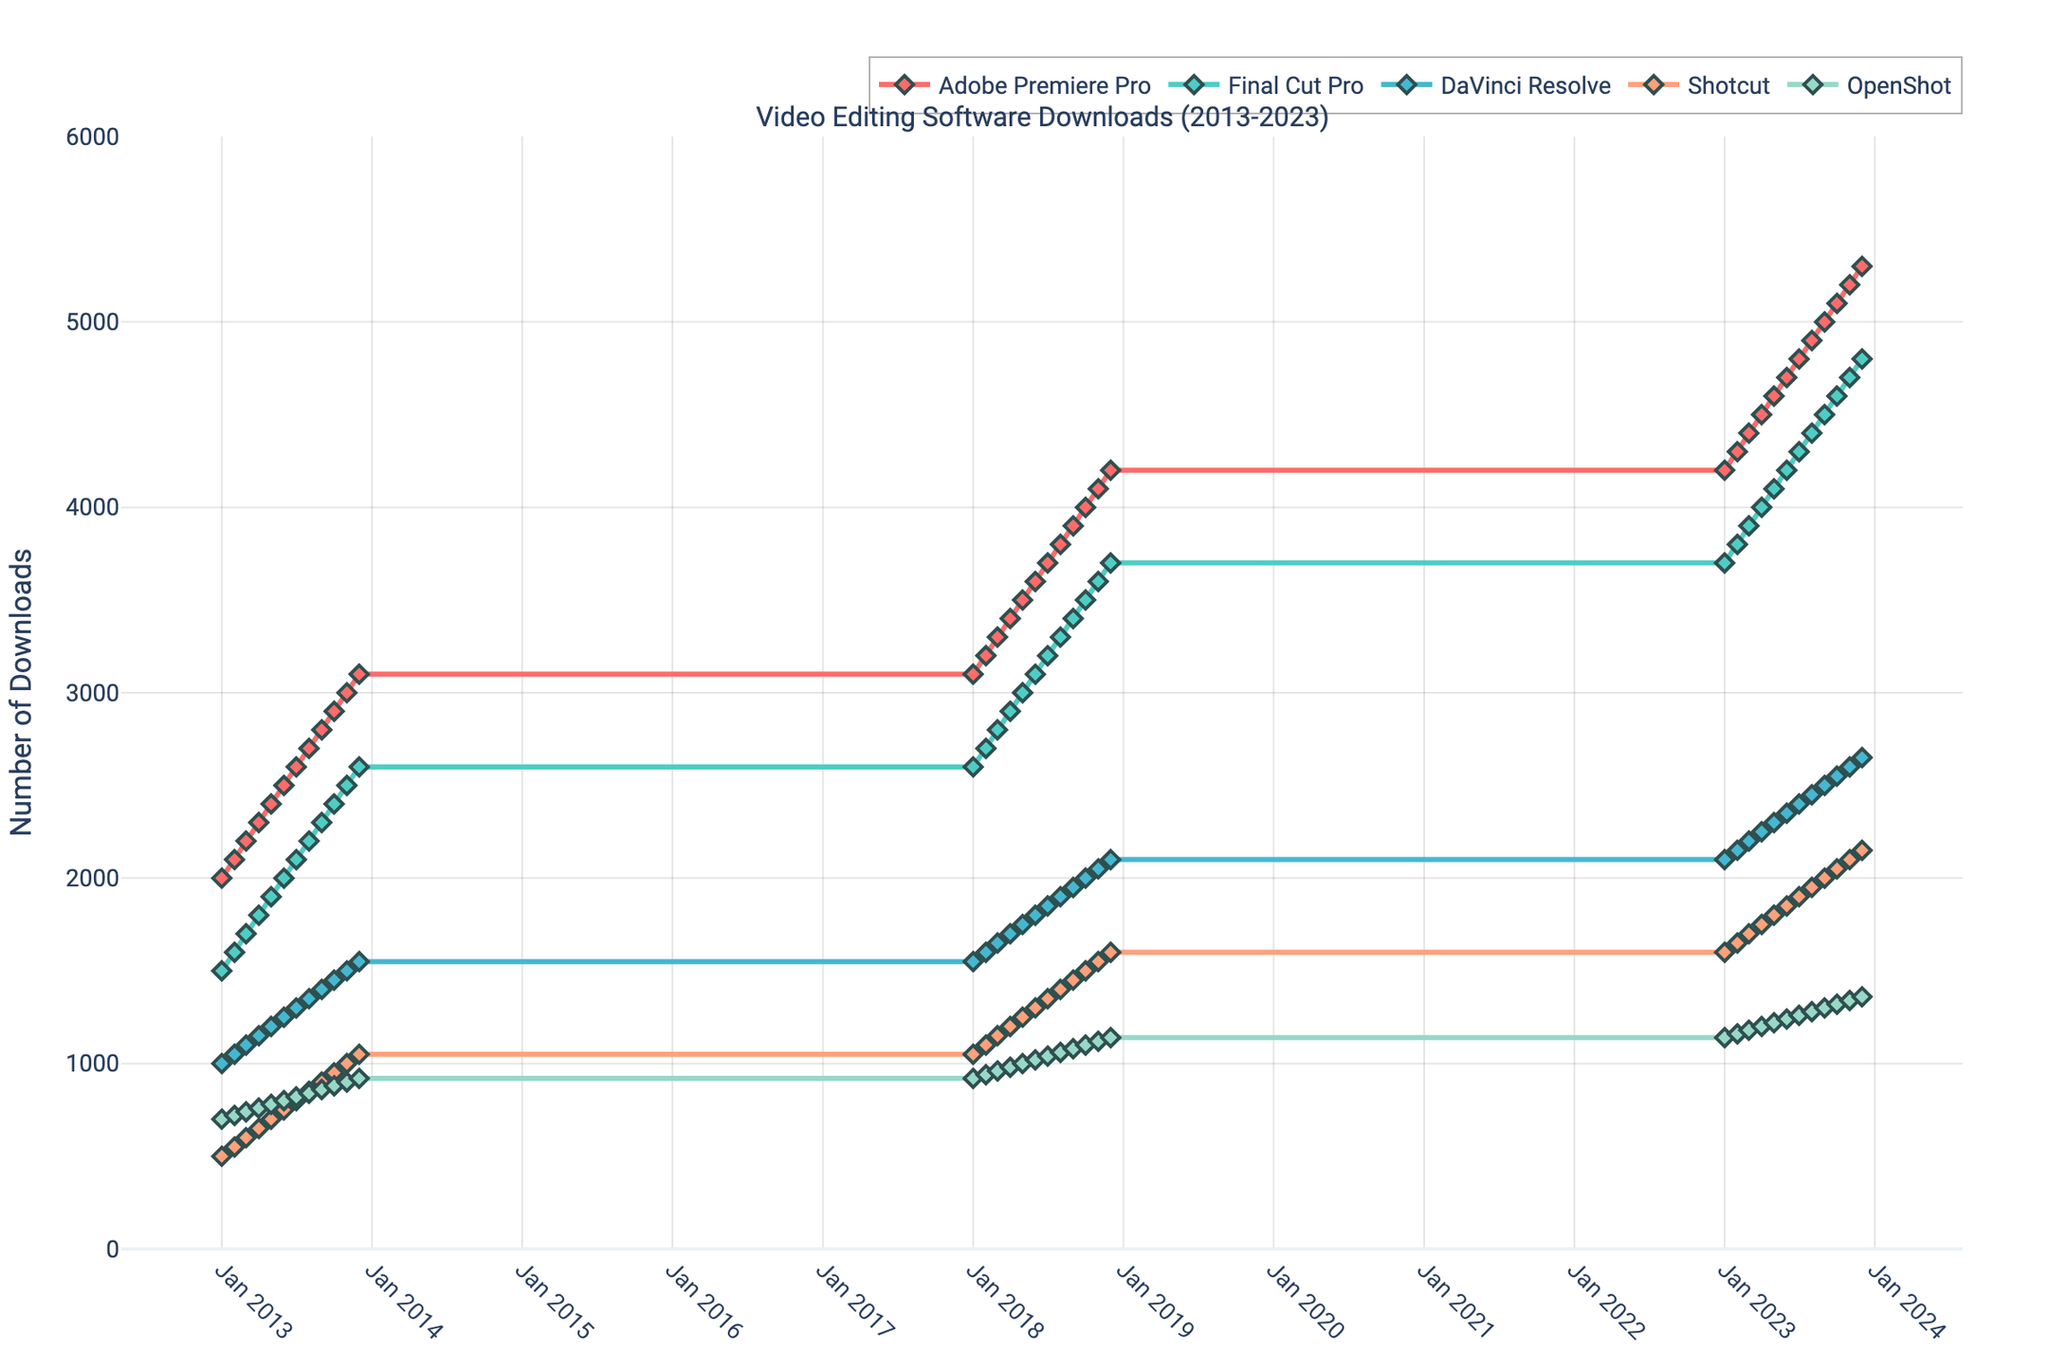What is the title of the figure? The title is usually displayed prominently at the top of the figure. By reading the top section of the plot, you can identify the title.
Answer: Video Editing Software Downloads (2013-2023) How many different software tools are compared in the figure? The figure uses different colored lines to represent different software tools. Count the number of distinct lines in the legend.
Answer: 5 Which software had the highest number of downloads in December 2023? By locating the point corresponding to December 2023 on the x-axis and then checking the y-value for each software, we can identify which one has the highest y-value.
Answer: Adobe Premiere Pro How does the number of OpenShot downloads in January 2018 compare to January 2023? Locate the points for January 2018 and January 2023 on the timeline for OpenShot and compare their y-values.
Answer: Increased What is the overall trend of downloads for DaVinci Resolve from 2013 to 2023? Observe the direction of the line representing DaVinci Resolve. If it generally moves upwards over time, it indicates an increase.
Answer: Increasing Which software showed the least variation in downloads over the entire period? Look for the software whose line is the flattest, indicating the least change in y-value over time.
Answer: Shotcut What was the average number of downloads for Final Cut Pro in 2013? Sum the downloads of Final Cut Pro for all months in 2013 and divide by the number of months (12).
Answer: 2050 When did Adobe Premiere Pro first reach 4000 downloads? Trace the line for Adobe Premiere Pro and find the point where it first crosses the y-value of 4000, then identify the corresponding date.
Answer: October 2018 Which month typically showed the highest increase in downloads year over year for all software? Compare the increments in downloads for each month across different years. This requires looking at several points.
Answer: August Did any software show a clear seasonal pattern, for example, always increasing in the summer? Observe if any of the lines show a repeated upward trend during the summer months (June, July, August) over the years.
Answer: Yes, all software typically show increases during the summer 